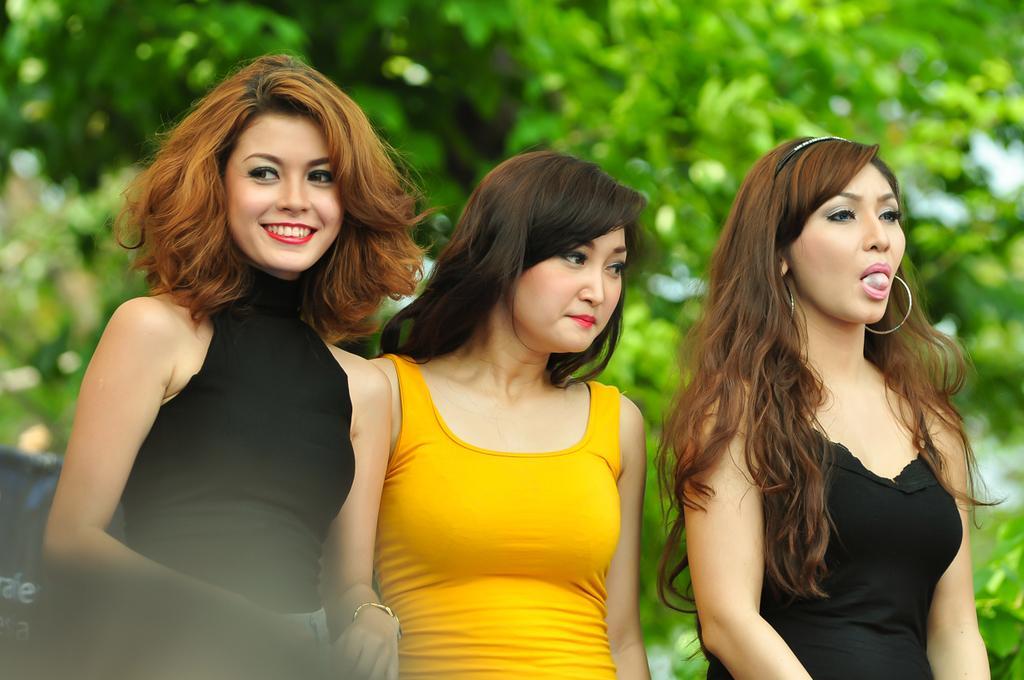How would you summarize this image in a sentence or two? In the image three women are standing and smiling. Behind them there are some trees. 